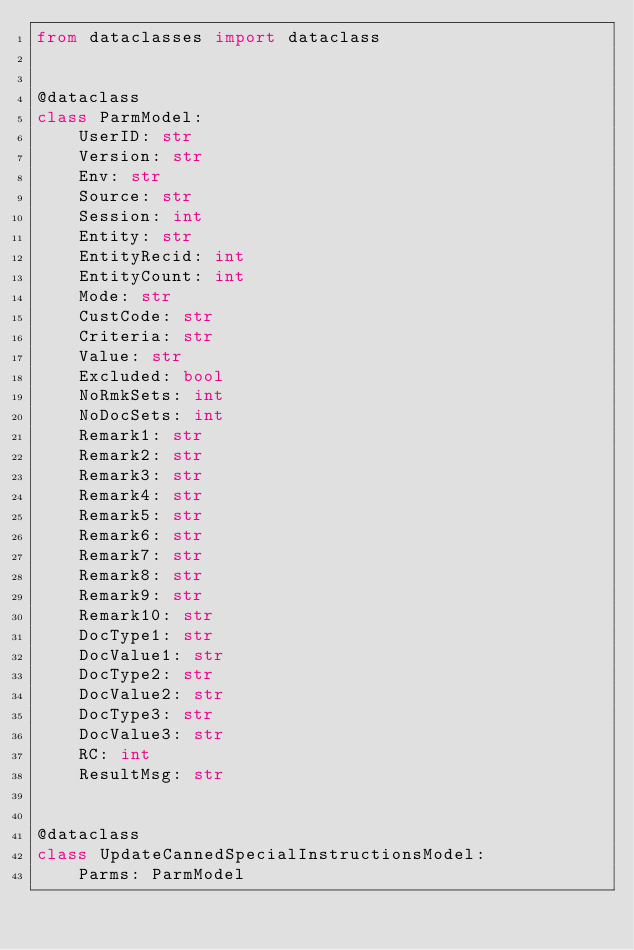<code> <loc_0><loc_0><loc_500><loc_500><_Python_>from dataclasses import dataclass


@dataclass
class ParmModel:
    UserID: str
    Version: str
    Env: str
    Source: str
    Session: int
    Entity: str
    EntityRecid: int
    EntityCount: int
    Mode: str
    CustCode: str
    Criteria: str
    Value: str
    Excluded: bool
    NoRmkSets: int
    NoDocSets: int
    Remark1: str
    Remark2: str
    Remark3: str
    Remark4: str
    Remark5: str
    Remark6: str
    Remark7: str
    Remark8: str
    Remark9: str
    Remark10: str
    DocType1: str
    DocValue1: str
    DocType2: str
    DocValue2: str
    DocType3: str
    DocValue3: str
    RC: int
    ResultMsg: str


@dataclass
class UpdateCannedSpecialInstructionsModel:
    Parms: ParmModel
</code> 